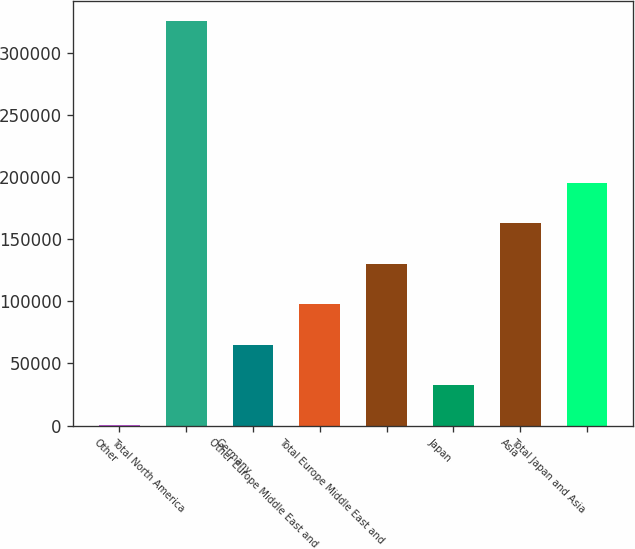<chart> <loc_0><loc_0><loc_500><loc_500><bar_chart><fcel>Other<fcel>Total North America<fcel>Germany<fcel>Other Europe Middle East and<fcel>Total Europe Middle East and<fcel>Japan<fcel>Asia<fcel>Total Japan and Asia<nl><fcel>108<fcel>325184<fcel>65123.2<fcel>97630.8<fcel>130138<fcel>32615.6<fcel>162646<fcel>195154<nl></chart> 